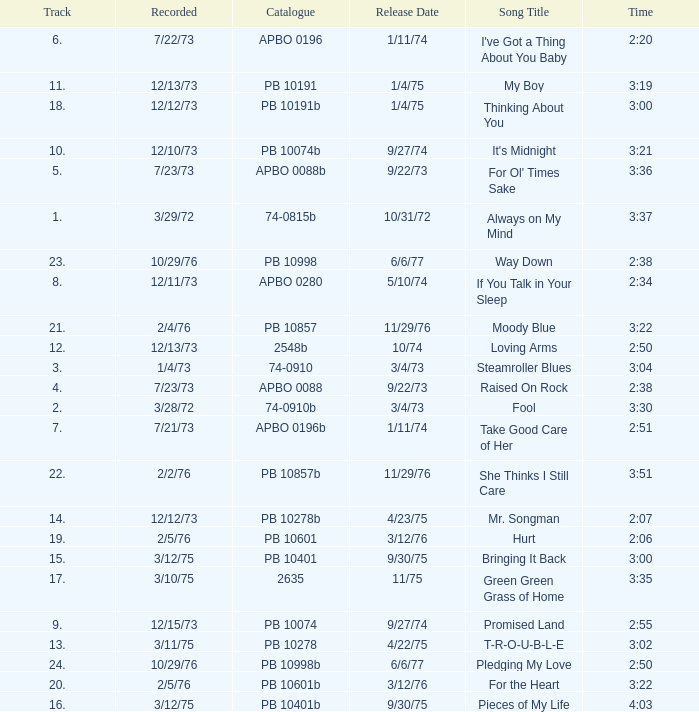Tell me the track that has the catalogue of apbo 0280 8.0. 